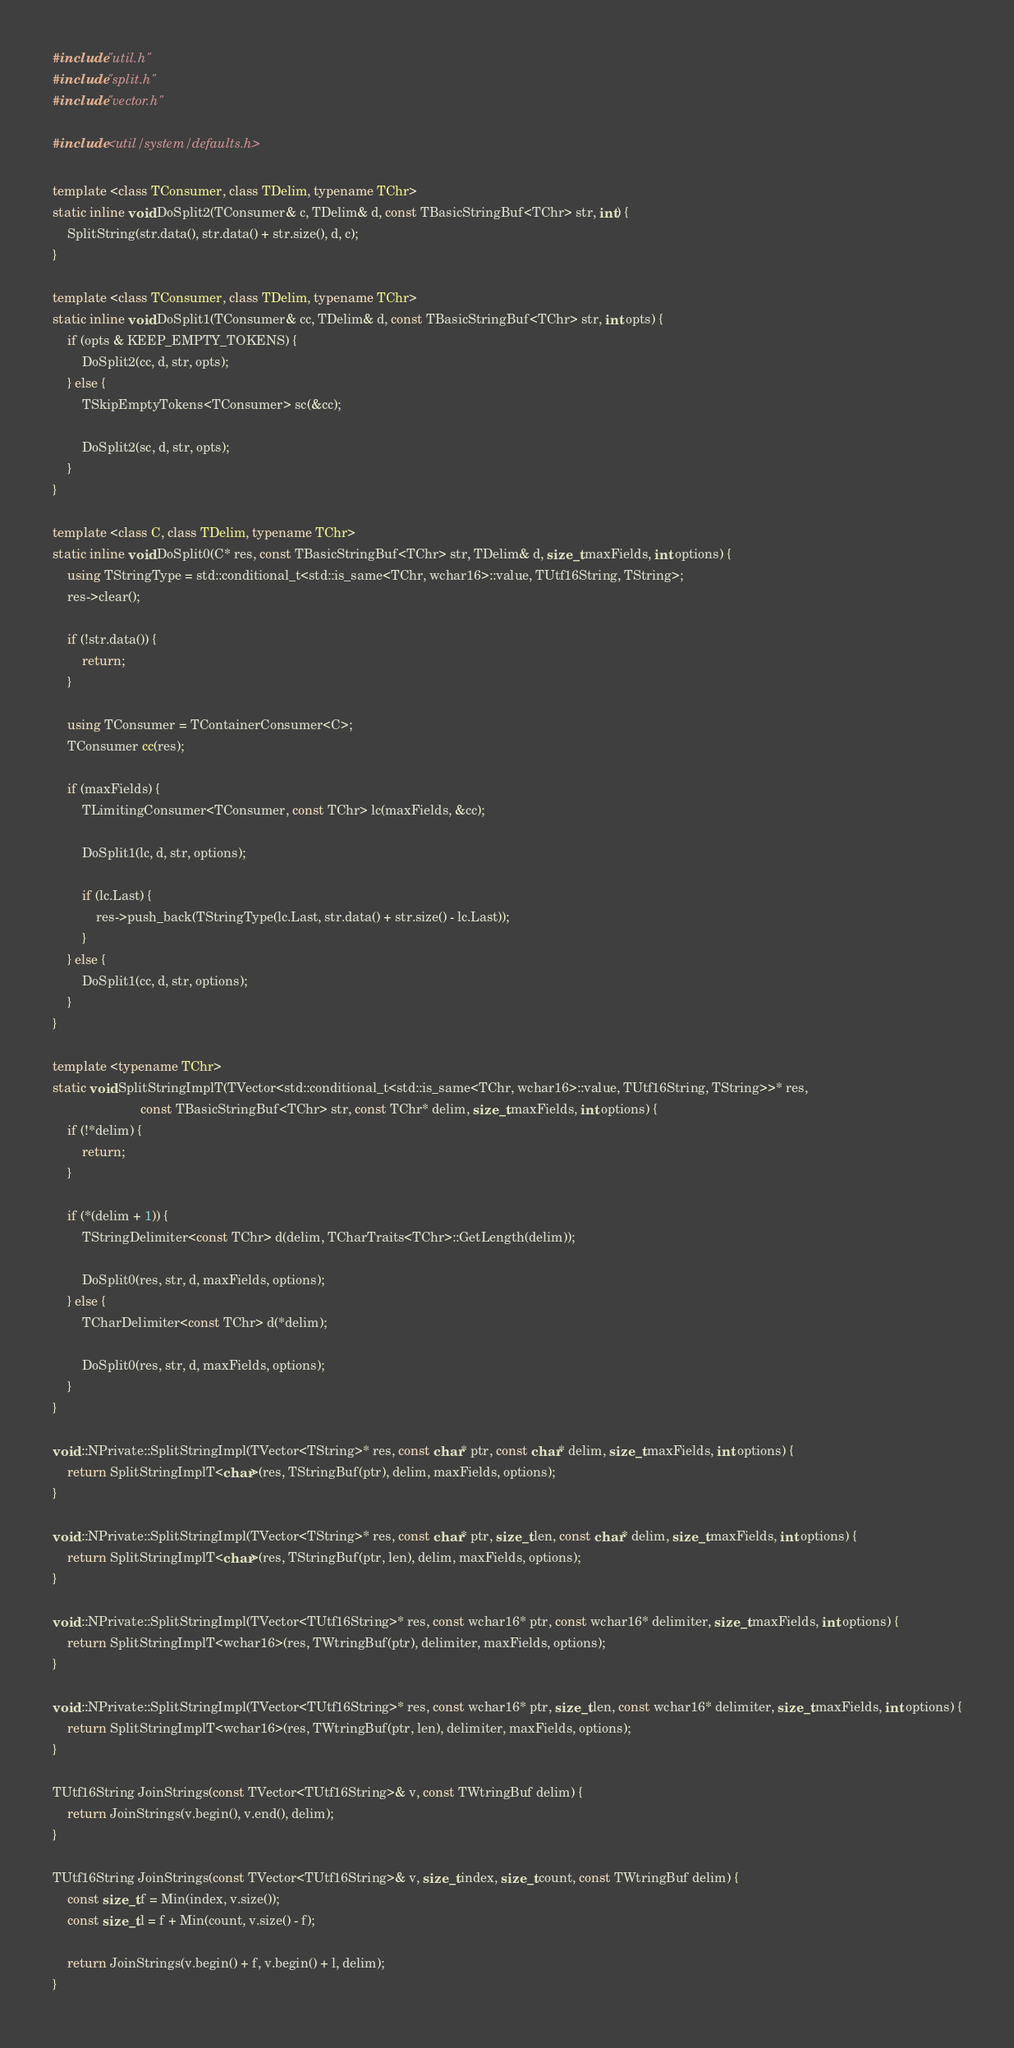Convert code to text. <code><loc_0><loc_0><loc_500><loc_500><_C++_>#include "util.h"
#include "split.h"
#include "vector.h"

#include <util/system/defaults.h>

template <class TConsumer, class TDelim, typename TChr>
static inline void DoSplit2(TConsumer& c, TDelim& d, const TBasicStringBuf<TChr> str, int) {
    SplitString(str.data(), str.data() + str.size(), d, c);
}

template <class TConsumer, class TDelim, typename TChr>
static inline void DoSplit1(TConsumer& cc, TDelim& d, const TBasicStringBuf<TChr> str, int opts) {
    if (opts & KEEP_EMPTY_TOKENS) {
        DoSplit2(cc, d, str, opts);
    } else {
        TSkipEmptyTokens<TConsumer> sc(&cc);

        DoSplit2(sc, d, str, opts);
    }
}

template <class C, class TDelim, typename TChr>
static inline void DoSplit0(C* res, const TBasicStringBuf<TChr> str, TDelim& d, size_t maxFields, int options) {
    using TStringType = std::conditional_t<std::is_same<TChr, wchar16>::value, TUtf16String, TString>;
    res->clear();

    if (!str.data()) {
        return;
    }

    using TConsumer = TContainerConsumer<C>;
    TConsumer cc(res);

    if (maxFields) {
        TLimitingConsumer<TConsumer, const TChr> lc(maxFields, &cc);

        DoSplit1(lc, d, str, options);

        if (lc.Last) {
            res->push_back(TStringType(lc.Last, str.data() + str.size() - lc.Last));
        }
    } else {
        DoSplit1(cc, d, str, options);
    }
}

template <typename TChr>
static void SplitStringImplT(TVector<std::conditional_t<std::is_same<TChr, wchar16>::value, TUtf16String, TString>>* res,
                        const TBasicStringBuf<TChr> str, const TChr* delim, size_t maxFields, int options) {
    if (!*delim) {
        return;
    }

    if (*(delim + 1)) {
        TStringDelimiter<const TChr> d(delim, TCharTraits<TChr>::GetLength(delim));

        DoSplit0(res, str, d, maxFields, options);
    } else {
        TCharDelimiter<const TChr> d(*delim);

        DoSplit0(res, str, d, maxFields, options);
    }
}

void ::NPrivate::SplitStringImpl(TVector<TString>* res, const char* ptr, const char* delim, size_t maxFields, int options) {
    return SplitStringImplT<char>(res, TStringBuf(ptr), delim, maxFields, options);
}

void ::NPrivate::SplitStringImpl(TVector<TString>* res, const char* ptr, size_t len, const char* delim, size_t maxFields, int options) {
    return SplitStringImplT<char>(res, TStringBuf(ptr, len), delim, maxFields, options);
}

void ::NPrivate::SplitStringImpl(TVector<TUtf16String>* res, const wchar16* ptr, const wchar16* delimiter, size_t maxFields, int options) {
    return SplitStringImplT<wchar16>(res, TWtringBuf(ptr), delimiter, maxFields, options);
}

void ::NPrivate::SplitStringImpl(TVector<TUtf16String>* res, const wchar16* ptr, size_t len, const wchar16* delimiter, size_t maxFields, int options) {
    return SplitStringImplT<wchar16>(res, TWtringBuf(ptr, len), delimiter, maxFields, options);
}

TUtf16String JoinStrings(const TVector<TUtf16String>& v, const TWtringBuf delim) {
    return JoinStrings(v.begin(), v.end(), delim);
}

TUtf16String JoinStrings(const TVector<TUtf16String>& v, size_t index, size_t count, const TWtringBuf delim) {
    const size_t f = Min(index, v.size());
    const size_t l = f + Min(count, v.size() - f);

    return JoinStrings(v.begin() + f, v.begin() + l, delim);
}
</code> 